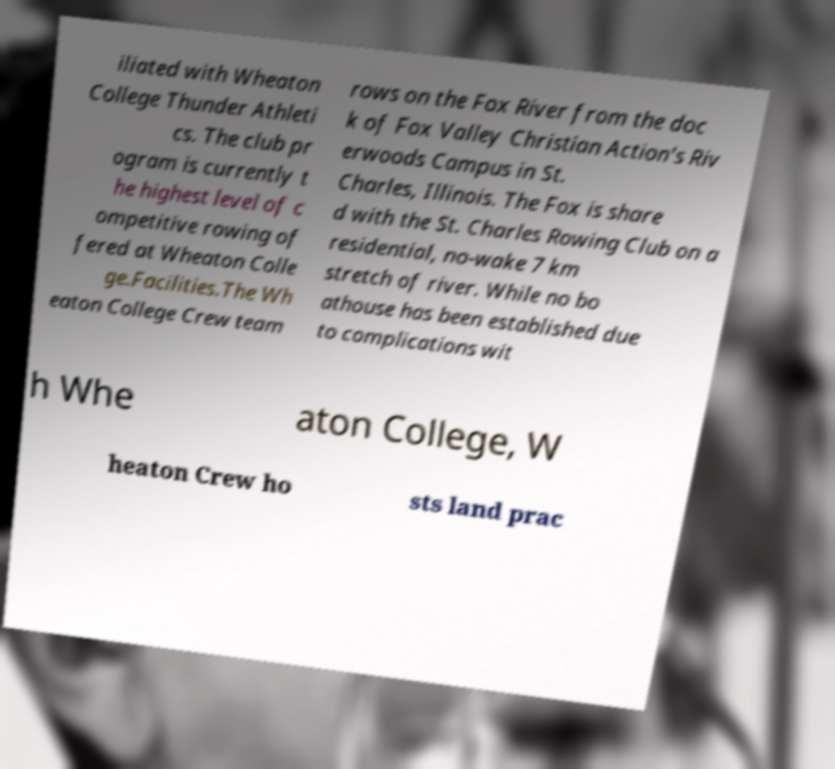Please identify and transcribe the text found in this image. iliated with Wheaton College Thunder Athleti cs. The club pr ogram is currently t he highest level of c ompetitive rowing of fered at Wheaton Colle ge.Facilities.The Wh eaton College Crew team rows on the Fox River from the doc k of Fox Valley Christian Action's Riv erwoods Campus in St. Charles, Illinois. The Fox is share d with the St. Charles Rowing Club on a residential, no-wake 7 km stretch of river. While no bo athouse has been established due to complications wit h Whe aton College, W heaton Crew ho sts land prac 